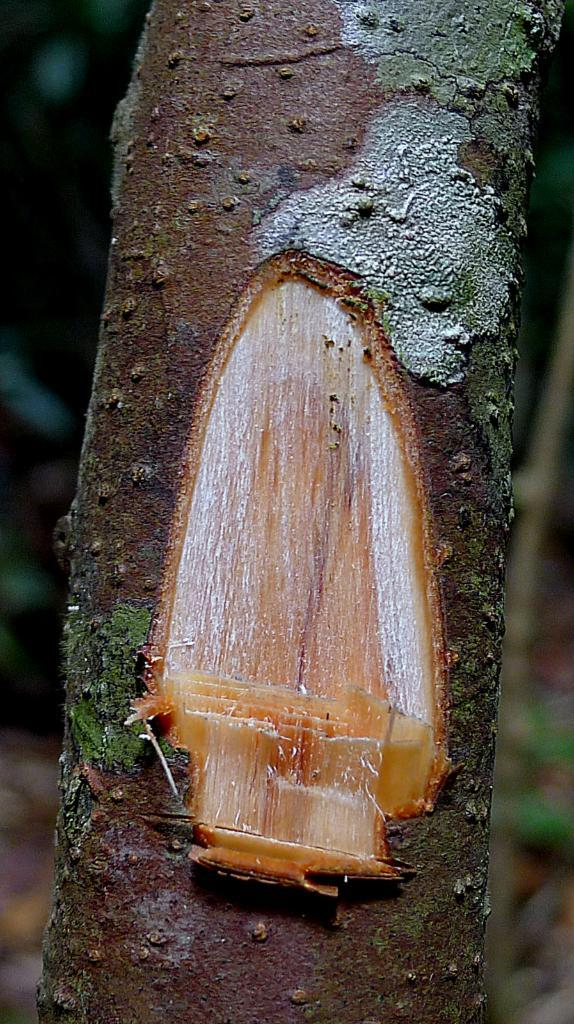What is the main subject of the image? The main subject of the image is a branch of a tree. What has been done to the branch? Slices have been chopped from the branch. How many eyes can be seen on the branch in the image? There are no eyes present on the branch in the image. 